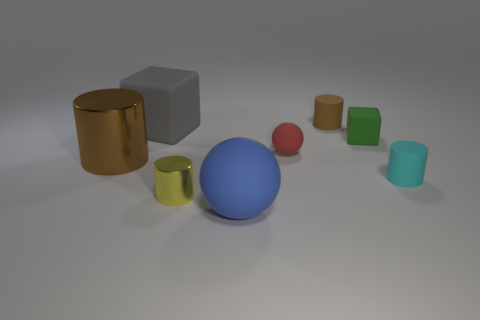Are the blue thing and the yellow thing made of the same material?
Your response must be concise. No. What number of things are blue matte things or small red metal cylinders?
Offer a terse response. 1. The brown object in front of the tiny brown thing has what shape?
Offer a very short reply. Cylinder. What is the color of the large object that is the same material as the big cube?
Your response must be concise. Blue. What material is the blue thing that is the same shape as the tiny red thing?
Provide a short and direct response. Rubber. What shape is the tiny green rubber thing?
Your answer should be very brief. Cube. What is the material of the thing that is both to the left of the blue rubber ball and behind the red matte thing?
Ensure brevity in your answer.  Rubber. There is a gray thing that is made of the same material as the small green block; what is its shape?
Offer a very short reply. Cube. There is a brown cylinder that is the same material as the large gray block; what size is it?
Provide a short and direct response. Small. What is the shape of the tiny matte thing that is in front of the green matte object and left of the green matte object?
Your answer should be compact. Sphere. 